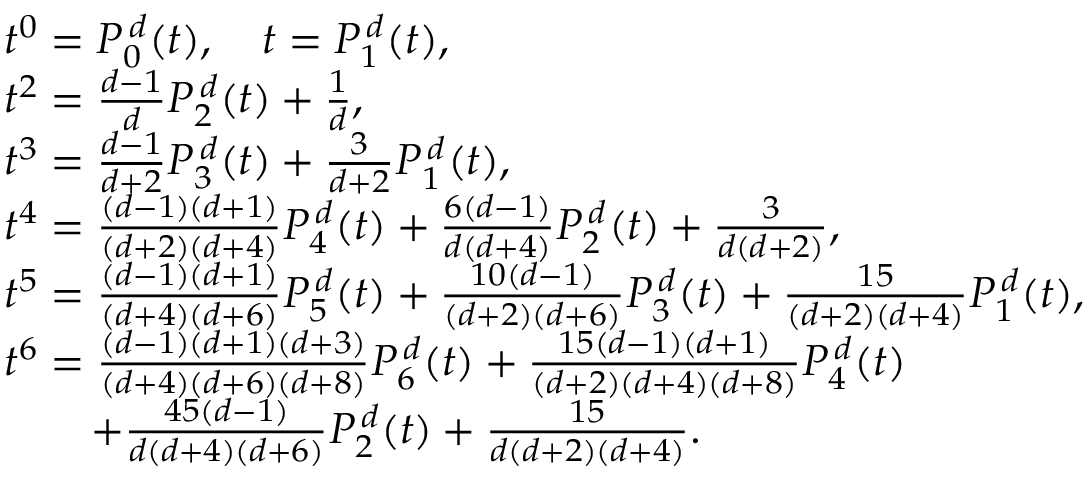<formula> <loc_0><loc_0><loc_500><loc_500>\begin{array} { r l } & { t ^ { 0 } = P _ { 0 } ^ { \, d } ( t ) , \quad t = P _ { 1 } ^ { \, d } ( t ) , } \\ & { t ^ { 2 } = \frac { d - 1 } { d } P _ { 2 } ^ { \, d } ( t ) + \frac { 1 } { d } , } \\ & { t ^ { 3 } = \frac { d - 1 } { d + 2 } P _ { 3 } ^ { \, d } ( t ) + \frac { 3 } { d + 2 } P _ { 1 } ^ { \, d } ( t ) , } \\ & { t ^ { 4 } = \frac { ( d - 1 ) ( d + 1 ) } { ( d + 2 ) ( d + 4 ) } P _ { 4 } ^ { \, d } ( t ) + \frac { 6 ( d - 1 ) } { d ( d + 4 ) } P _ { 2 } ^ { \, d } ( t ) + \frac { 3 } { d ( d + 2 ) } , } \\ & { t ^ { 5 } = \frac { ( d - 1 ) ( d + 1 ) } { ( d + 4 ) ( d + 6 ) } P _ { 5 } ^ { \, d } ( t ) + \frac { 1 0 ( d - 1 ) } { ( d + 2 ) ( d + 6 ) } P _ { 3 } ^ { \, d } ( t ) + \frac { 1 5 } { ( d + 2 ) ( d + 4 ) } P _ { 1 } ^ { \, d } ( t ) , } \\ & { t ^ { 6 } = \frac { ( d - 1 ) ( d + 1 ) ( d + 3 ) } { ( d + 4 ) ( d + 6 ) ( d + 8 ) } P _ { 6 } ^ { \, d } ( t ) + \frac { 1 5 ( d - 1 ) ( d + 1 ) } { ( d + 2 ) ( d + 4 ) ( d + 8 ) } P _ { 4 } ^ { \, d } ( t ) } \\ & { \quad + \frac { 4 5 ( d - 1 ) } { d ( d + 4 ) ( d + 6 ) } P _ { 2 } ^ { \, d } ( t ) + \frac { 1 5 } { d ( d + 2 ) ( d + 4 ) } . } \end{array}</formula> 